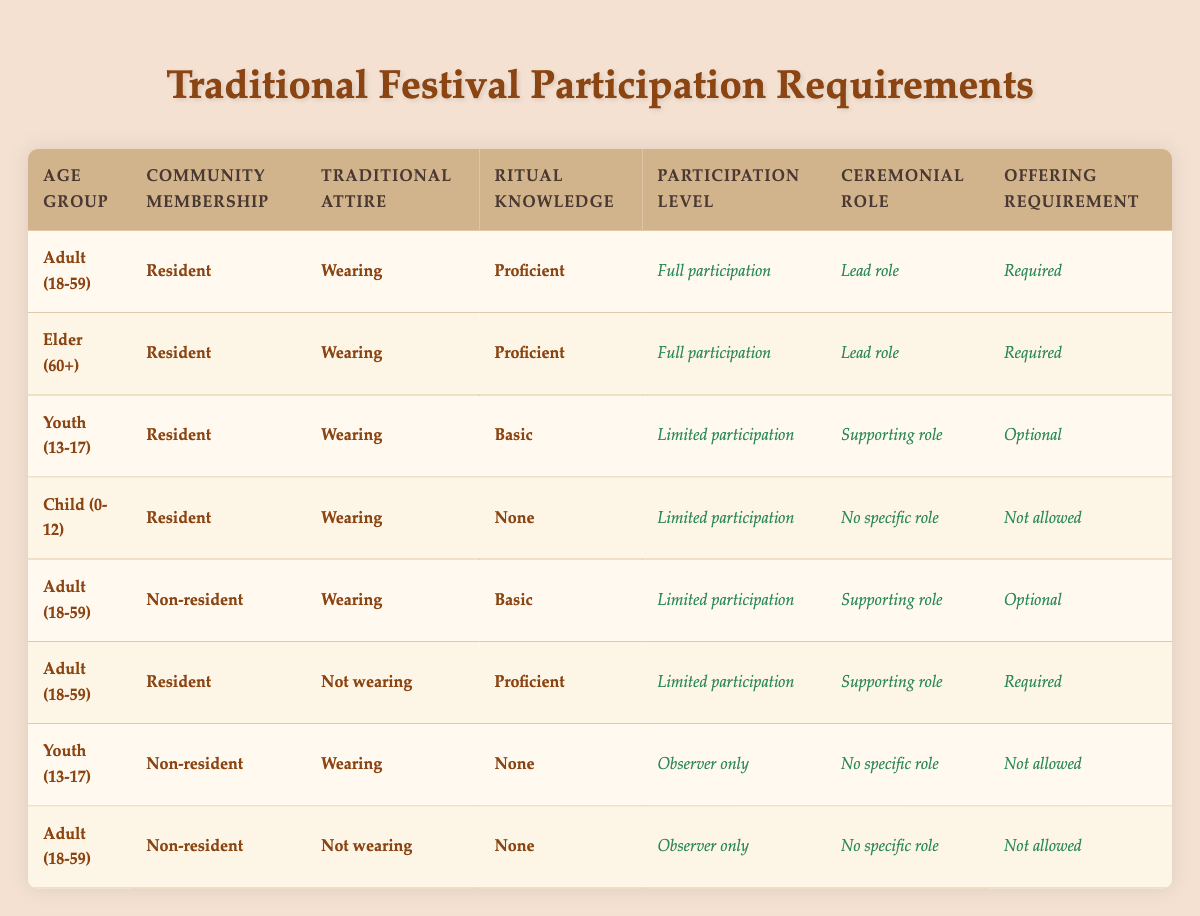What are the participation levels for residents wearing traditional attire and having proficient ritual knowledge? In the table, we examine rows where 'Community Membership' is 'Resident', 'Traditional Attire' is 'Wearing', and 'Ritual Knowledge' is 'Proficient'. There are two relevant entries: one for Adults (18-59) and one for Elders (60+). Both have the action of 'Full participation'.
Answer: Full participation Which age group can be an observer only if they are non-residents and not wearing traditional attire? Looking for entries with 'Community Membership' as 'Non-resident' and 'Traditional Attire' as 'Not wearing' indicates we should check the appropriate age groups. There are two entries under these conditions: both the Adult (18-59) and Youth (13-17) groups are classified as 'Observer only'.
Answer: Adult (18-59) and Youth (13-17) How many different combinations of age groups and community memberships are eligible for full participation? Full participation only applies to two combinations based on the data: 'Adult (18-59)' with 'Resident' and 'Elder (60+)' with 'Resident'. Therefore, there are two distinct combinations: one for Adults and one for Elders.
Answer: 2 Is it true that wearing traditional attire and having basic ritual knowledge allows youth to have a supporting role? Checking the table, we find that for Youth (13-17) who are 'Resident', 'Wearing', and have 'Basic' ritual knowledge, the result is 'Limited participation' with a 'Supporting role'. Thus, it is not true that they have a supporting role; it's limited participation.
Answer: No What is the requirement for offering from adults who are residents, not wearing traditional attire, and have proficient ritual knowledge? Review the conditions for 'Adult (18-59)', 'Resident', 'Not wearing', and 'Proficient' in the table. The result indicates they have 'Limited participation', 'Supporting role', and the 'Offering Requirement' is 'Required'.
Answer: Required How many participants can fully participate without needing to provide an offering? From the table, both 'Adult (18-59)' and 'Elder (60+)', who are residents, wearing traditional attire, and proficient in ritual knowledge, are eligible for full participation. Both require offerings, thus no participants can fully participate without offering.
Answer: 0 What roles can young non-residents have if they are not wearing traditional attire and have no ritual knowledge? The table indicates for 'Youth (13-17)', 'Non-resident', 'Not wearing', and 'None' for ritual knowledge, the participation level is 'Observer only' and 'No specific role'. Therefore, they can only be observers with no specific role.
Answer: Observer only Can adults who do not wear traditional attire and are non-residents with no ritual knowledge participate at all? According to the rules in the table, Adults (18-59) who are 'Non-resident', 'Not wearing', and have 'None' for ritual knowledge are classified as 'Observer only' with 'No specific role'. This indicates they participate but with very limited involvement.
Answer: Yes 